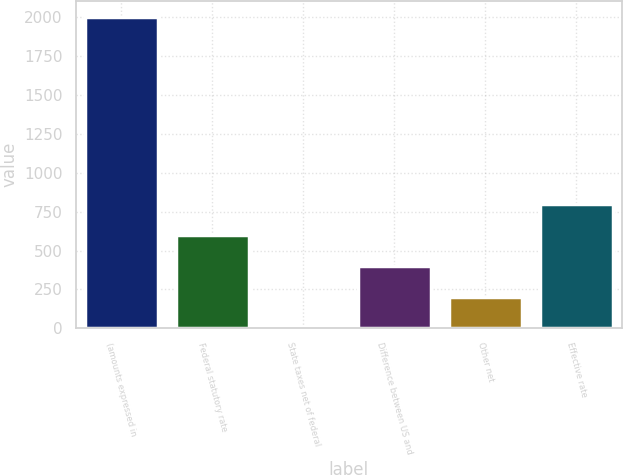Convert chart to OTSL. <chart><loc_0><loc_0><loc_500><loc_500><bar_chart><fcel>(amounts expressed in<fcel>Federal statutory rate<fcel>State taxes net of federal<fcel>Difference between US and<fcel>Other net<fcel>Effective rate<nl><fcel>2003<fcel>601.18<fcel>0.4<fcel>400.92<fcel>200.66<fcel>801.44<nl></chart> 